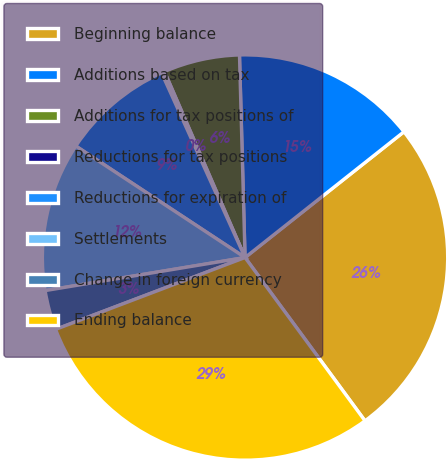<chart> <loc_0><loc_0><loc_500><loc_500><pie_chart><fcel>Beginning balance<fcel>Additions based on tax<fcel>Additions for tax positions of<fcel>Reductions for tax positions<fcel>Reductions for expiration of<fcel>Settlements<fcel>Change in foreign currency<fcel>Ending balance<nl><fcel>25.57%<fcel>14.78%<fcel>6.07%<fcel>0.25%<fcel>8.97%<fcel>11.88%<fcel>3.16%<fcel>29.31%<nl></chart> 